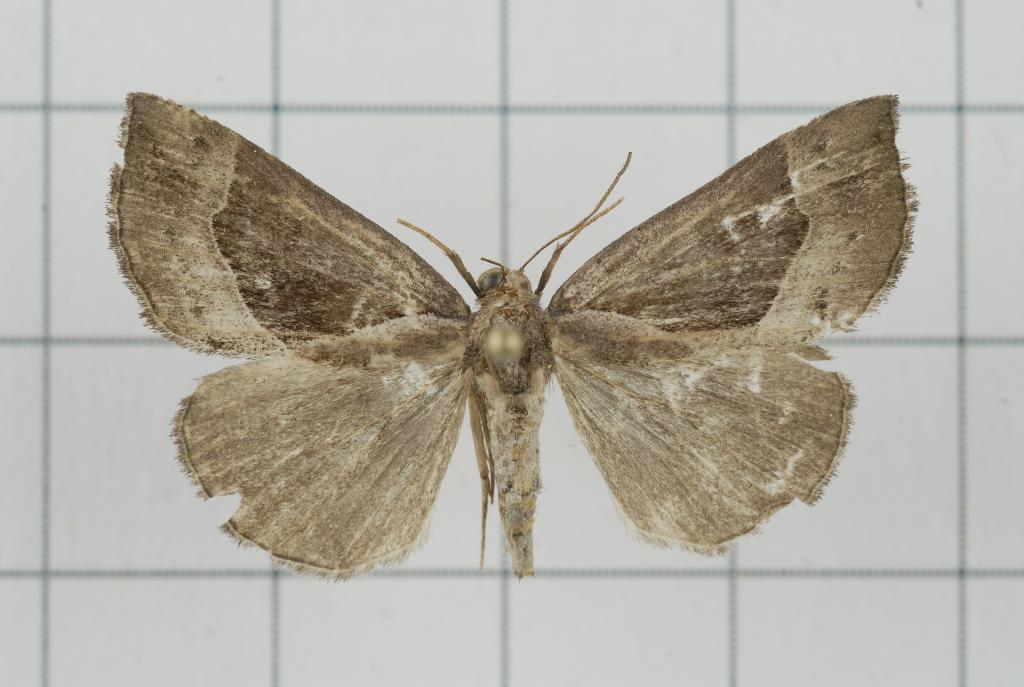Please provide a concise description of this image. In this picture we can see a butterfly on the white floor. 